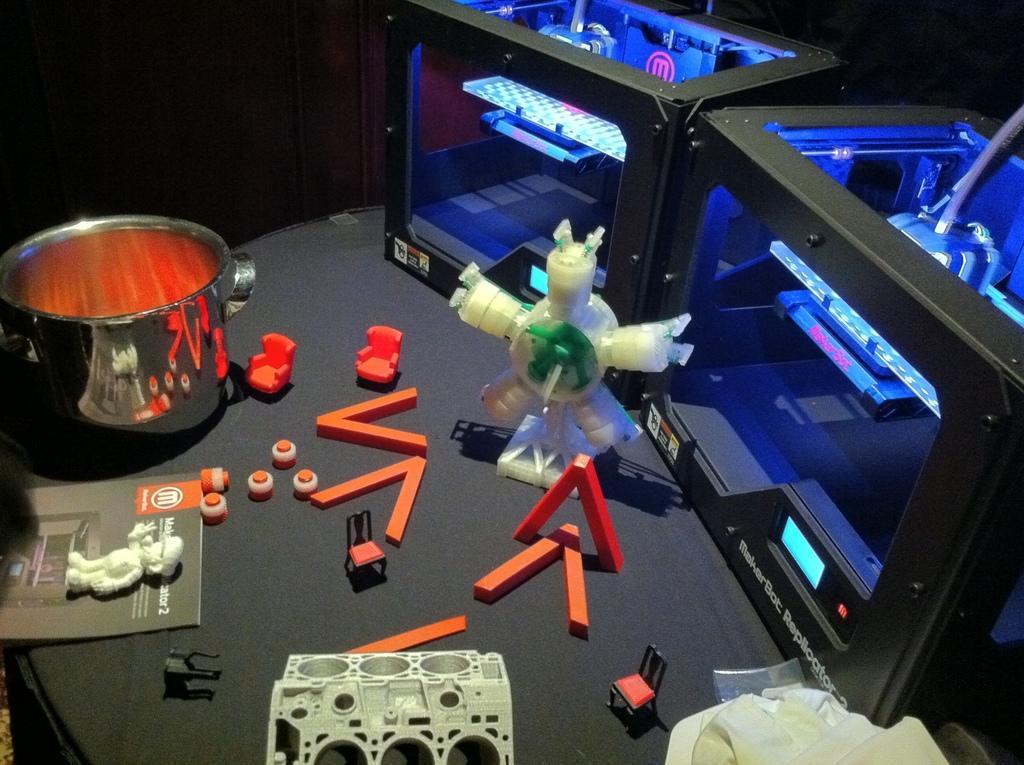How would you summarize this image in a sentence or two? In this image we can see a bowl, a book and few objects looks like toys and two machines on the table. 